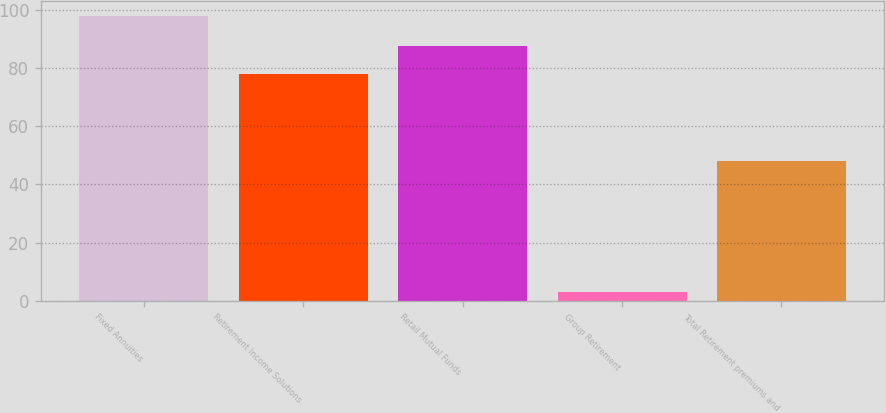<chart> <loc_0><loc_0><loc_500><loc_500><bar_chart><fcel>Fixed Annuities<fcel>Retirement Income Solutions<fcel>Retail Mutual Funds<fcel>Group Retirement<fcel>Total Retirement premiums and<nl><fcel>98<fcel>78<fcel>87.5<fcel>3<fcel>48<nl></chart> 